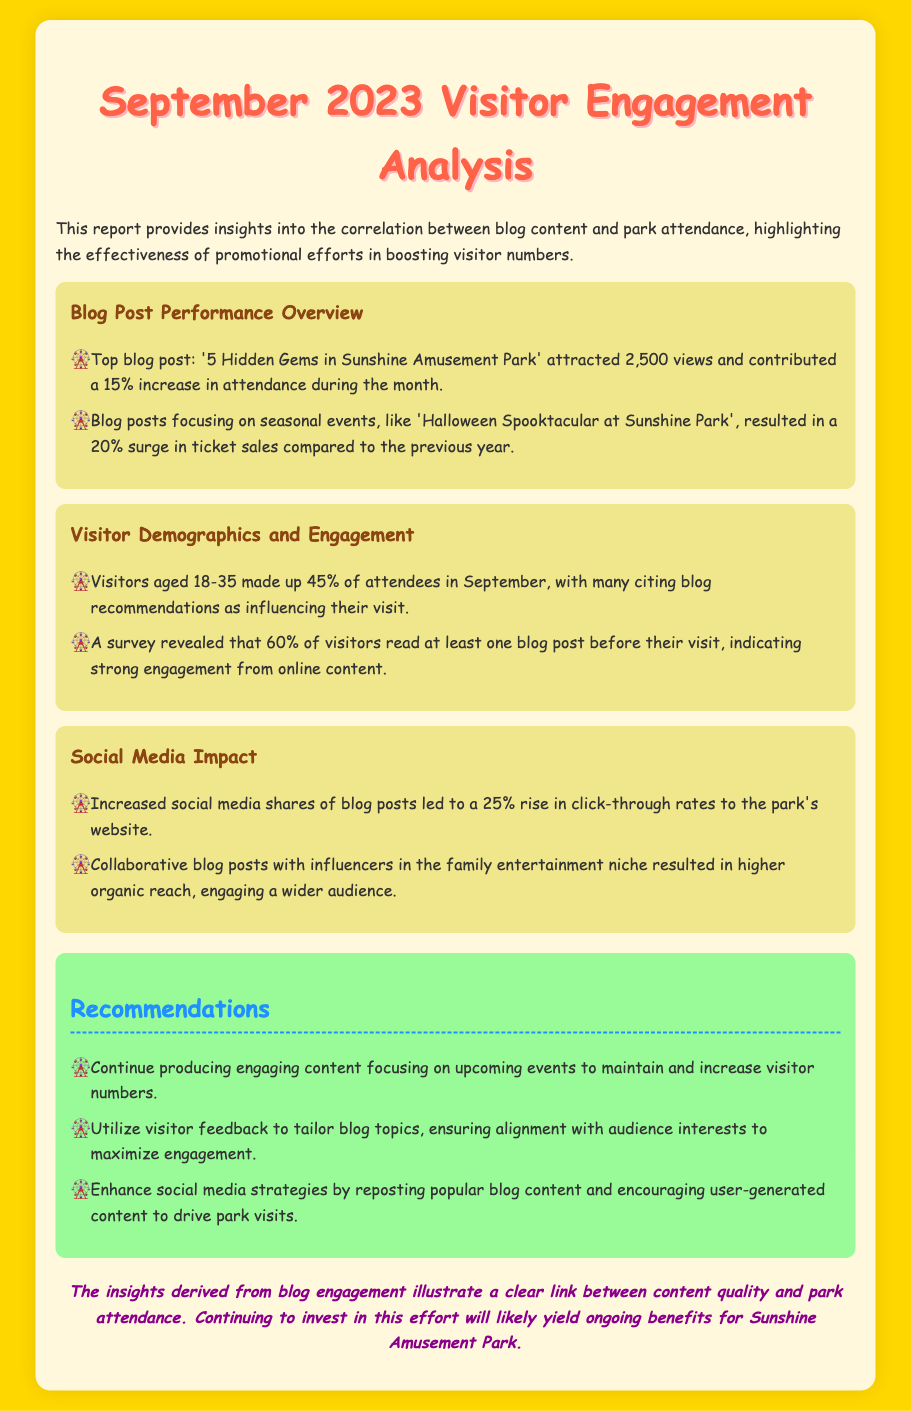What is the top blog post? The document mentions the top blog post as '5 Hidden Gems in Sunshine Amusement Park'.
Answer: '5 Hidden Gems in Sunshine Amusement Park' What was the percentage increase in attendance due to the top blog post? The document states that the top blog post contributed a 15% increase in attendance.
Answer: 15% What percentage of visitors read at least one blog post before their visit? According to the survey mentioned, 60% of visitors read at least one blog post before their visit.
Answer: 60% What demographic made up 45% of attendees in September? The document indicates that visitors aged 18-35 made up 45% of attendees.
Answer: 18-35 What was the increase in click-through rates due to social media shares? The document notes a 25% rise in click-through rates to the park's website from increased social media shares.
Answer: 25% What type of blog posts resulted in a 20% surge in ticket sales? The document indicates that blog posts focusing on seasonal events resulted in the surge in ticket sales.
Answer: Seasonal events How many insights were provided in the report? The document presents three main insights regarding blog performance, visitor demographics, and social media impact.
Answer: Three What is the color theme used in the document's header? The header uses a color theme of #FF6347 for the main title.
Answer: #FF6347 What is the overall conclusion regarding the link between content and attendance? The conclusion states there is a clear link between content quality and park attendance.
Answer: Clear link 